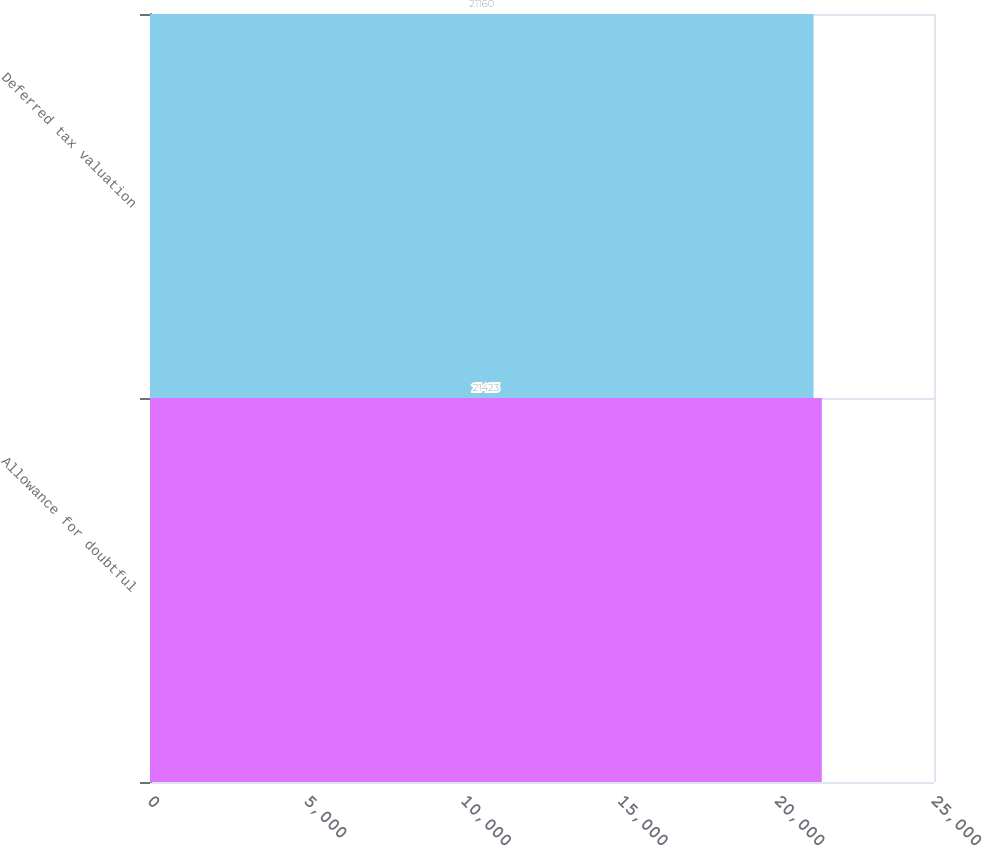Convert chart. <chart><loc_0><loc_0><loc_500><loc_500><bar_chart><fcel>Allowance for doubtful<fcel>Deferred tax valuation<nl><fcel>21423<fcel>21160<nl></chart> 